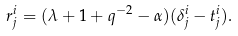Convert formula to latex. <formula><loc_0><loc_0><loc_500><loc_500>r _ { j } ^ { i } = ( \lambda + 1 + q ^ { - 2 } - \alpha ) ( \delta _ { j } ^ { i } - t _ { j } ^ { i } ) .</formula> 